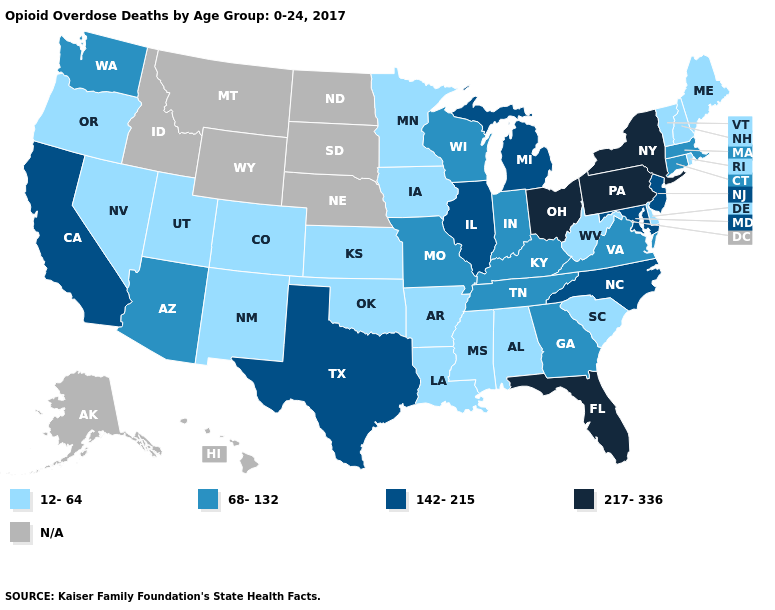What is the highest value in states that border Georgia?
Give a very brief answer. 217-336. Name the states that have a value in the range N/A?
Concise answer only. Alaska, Hawaii, Idaho, Montana, Nebraska, North Dakota, South Dakota, Wyoming. Name the states that have a value in the range 142-215?
Answer briefly. California, Illinois, Maryland, Michigan, New Jersey, North Carolina, Texas. Name the states that have a value in the range 68-132?
Answer briefly. Arizona, Connecticut, Georgia, Indiana, Kentucky, Massachusetts, Missouri, Tennessee, Virginia, Washington, Wisconsin. Name the states that have a value in the range N/A?
Give a very brief answer. Alaska, Hawaii, Idaho, Montana, Nebraska, North Dakota, South Dakota, Wyoming. Does the first symbol in the legend represent the smallest category?
Short answer required. Yes. What is the lowest value in states that border Delaware?
Answer briefly. 142-215. What is the highest value in states that border Nevada?
Be succinct. 142-215. Name the states that have a value in the range 217-336?
Concise answer only. Florida, New York, Ohio, Pennsylvania. Which states hav the highest value in the Northeast?
Give a very brief answer. New York, Pennsylvania. What is the highest value in states that border Mississippi?
Be succinct. 68-132. What is the value of Minnesota?
Concise answer only. 12-64. Name the states that have a value in the range 12-64?
Quick response, please. Alabama, Arkansas, Colorado, Delaware, Iowa, Kansas, Louisiana, Maine, Minnesota, Mississippi, Nevada, New Hampshire, New Mexico, Oklahoma, Oregon, Rhode Island, South Carolina, Utah, Vermont, West Virginia. Does the first symbol in the legend represent the smallest category?
Quick response, please. Yes. 